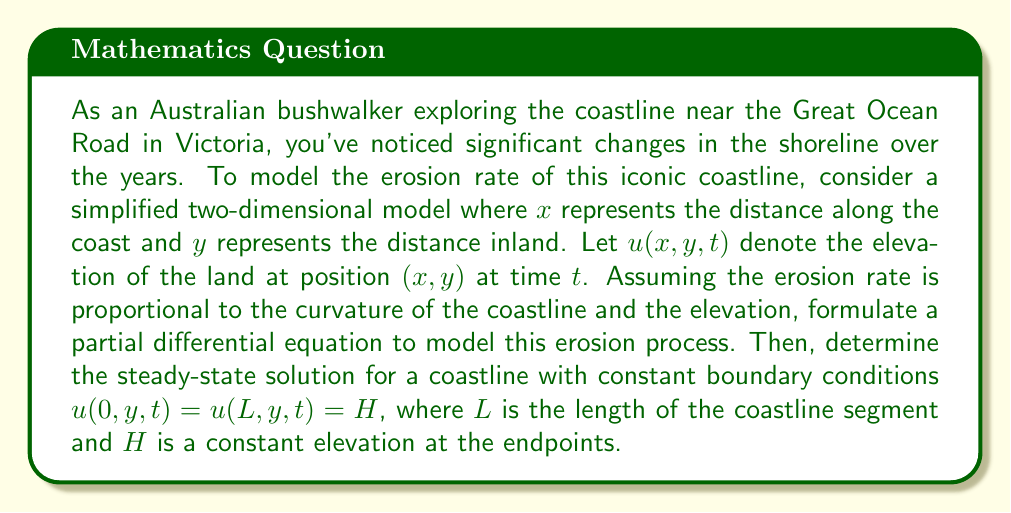Solve this math problem. To model the erosion rate of the coastline, we need to consider how the elevation changes over time. Let's break this down step-by-step:

1) The erosion rate is assumed to be proportional to two factors:
   a) The curvature of the coastline, which can be approximated by $\frac{\partial^2u}{\partial x^2}$
   b) The elevation $u$

2) We can express this mathematically as:

   $$\frac{\partial u}{\partial t} = k\left(\frac{\partial^2u}{\partial x^2} + \alpha u\right)$$

   where $k$ is a constant representing the erosion rate, and $\alpha$ is another constant.

3) This is our partial differential equation (PDE) modeling the erosion process.

4) To find the steady-state solution, we set $\frac{\partial u}{\partial t} = 0$:

   $$0 = k\left(\frac{\partial^2u}{\partial x^2} + \alpha u\right)$$

5) Simplifying:

   $$\frac{\partial^2u}{\partial x^2} + \alpha u = 0$$

6) This is a second-order ordinary differential equation in $x$. The general solution is:

   $$u(x) = A \cos(\sqrt{\alpha}x) + B \sin(\sqrt{\alpha}x)$$

7) Applying the boundary conditions:
   At $x = 0$: $u(0) = H = A$
   At $x = L$: $u(L) = H = A \cos(\sqrt{\alpha}L) + B \sin(\sqrt{\alpha}L)$

8) From the first condition, $A = H$. Substituting this into the second condition:

   $$H = H \cos(\sqrt{\alpha}L) + B \sin(\sqrt{\alpha}L)$$

9) Solving for $B$:

   $$B = \frac{H(1 - \cos(\sqrt{\alpha}L))}{\sin(\sqrt{\alpha}L)}$$

10) Therefore, the steady-state solution is:

    $$u(x) = H \cos(\sqrt{\alpha}x) + \frac{H(1 - \cos(\sqrt{\alpha}L))}{\sin(\sqrt{\alpha}L)} \sin(\sqrt{\alpha}x)$$
Answer: The steady-state solution for the coastline erosion model with constant boundary conditions is:

$$u(x) = H \cos(\sqrt{\alpha}x) + \frac{H(1 - \cos(\sqrt{\alpha}L))}{\sin(\sqrt{\alpha}L)} \sin(\sqrt{\alpha}x)$$

where $H$ is the constant elevation at the endpoints, $L$ is the length of the coastline segment, and $\alpha$ is a constant in the original PDE. 